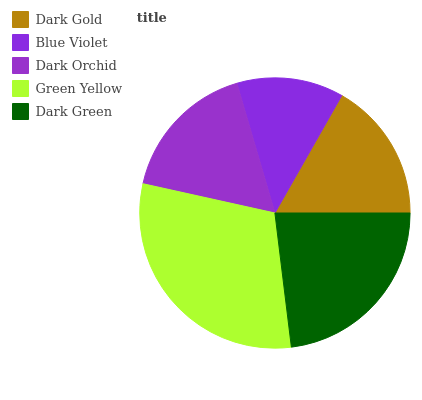Is Blue Violet the minimum?
Answer yes or no. Yes. Is Green Yellow the maximum?
Answer yes or no. Yes. Is Dark Orchid the minimum?
Answer yes or no. No. Is Dark Orchid the maximum?
Answer yes or no. No. Is Dark Orchid greater than Blue Violet?
Answer yes or no. Yes. Is Blue Violet less than Dark Orchid?
Answer yes or no. Yes. Is Blue Violet greater than Dark Orchid?
Answer yes or no. No. Is Dark Orchid less than Blue Violet?
Answer yes or no. No. Is Dark Orchid the high median?
Answer yes or no. Yes. Is Dark Orchid the low median?
Answer yes or no. Yes. Is Blue Violet the high median?
Answer yes or no. No. Is Dark Green the low median?
Answer yes or no. No. 